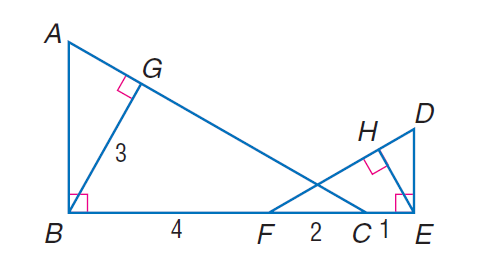Question: Find E H if \triangle A B C \sim \triangle D E F, B G is an altitude of \triangle A B C, E H is an altitude of \triangle D E F, B G = 3, B F = 4, F C = 2, and C E = 1.
Choices:
A. 1
B. \frac { 3 } { 2 }
C. 2
D. 3
Answer with the letter. Answer: B 